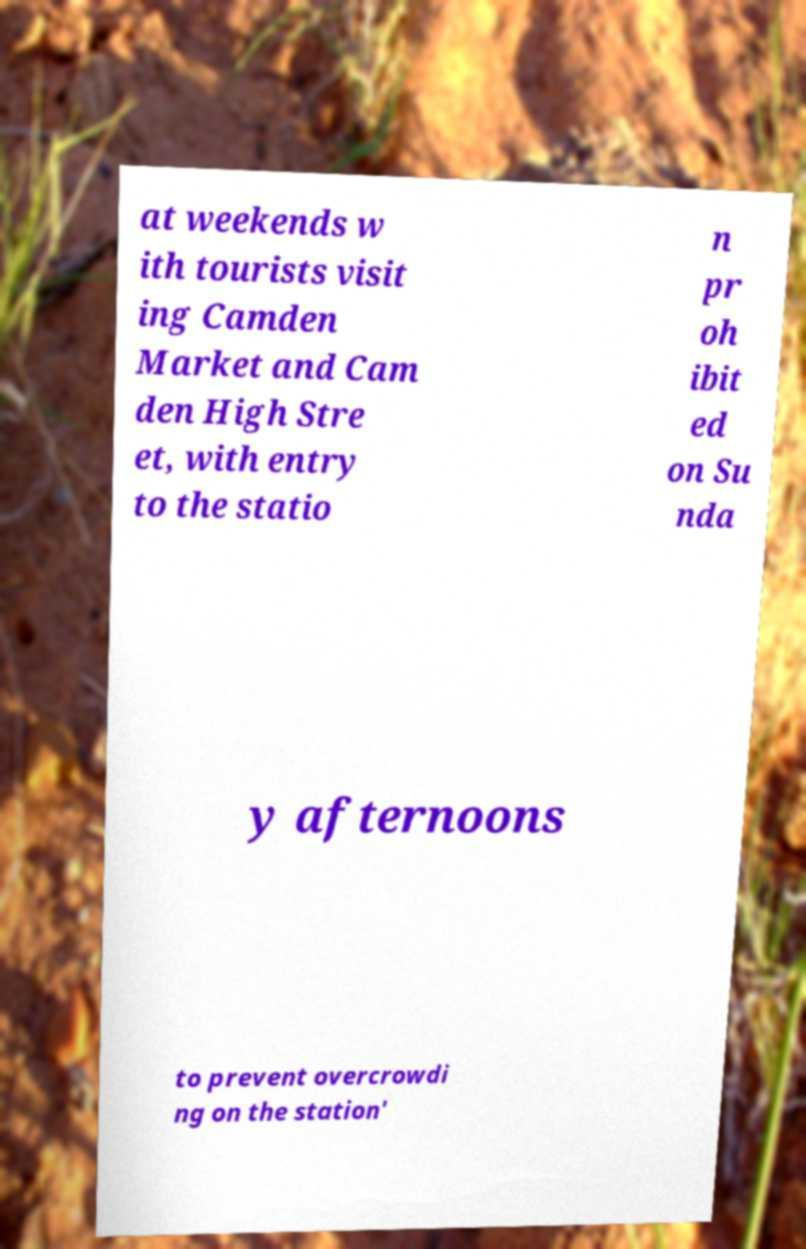Could you extract and type out the text from this image? at weekends w ith tourists visit ing Camden Market and Cam den High Stre et, with entry to the statio n pr oh ibit ed on Su nda y afternoons to prevent overcrowdi ng on the station' 